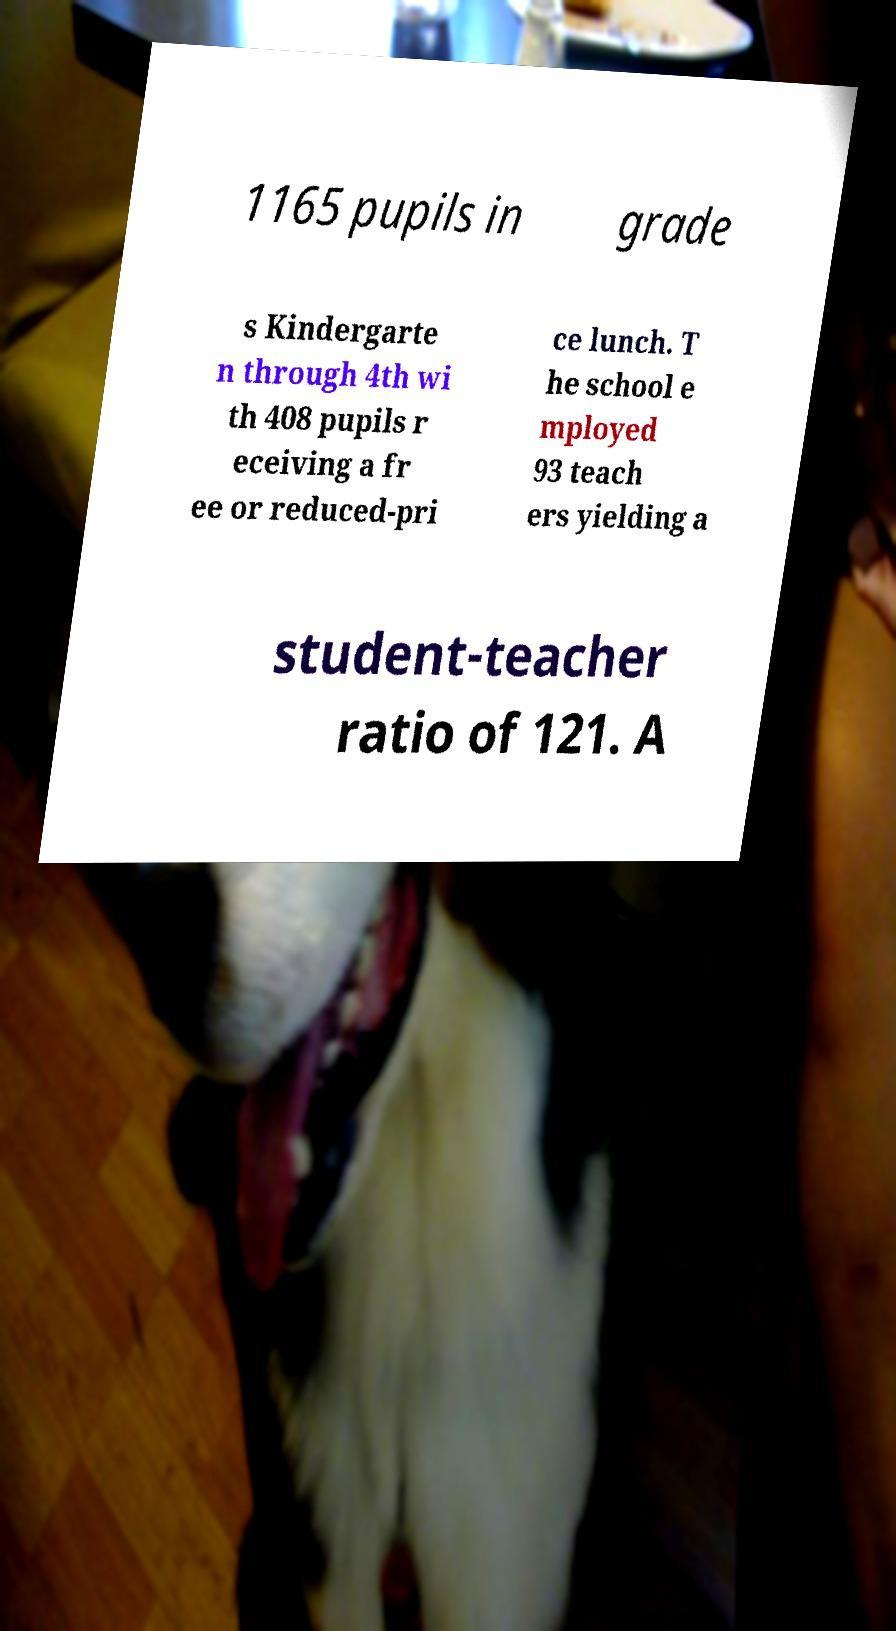Could you assist in decoding the text presented in this image and type it out clearly? 1165 pupils in grade s Kindergarte n through 4th wi th 408 pupils r eceiving a fr ee or reduced-pri ce lunch. T he school e mployed 93 teach ers yielding a student-teacher ratio of 121. A 